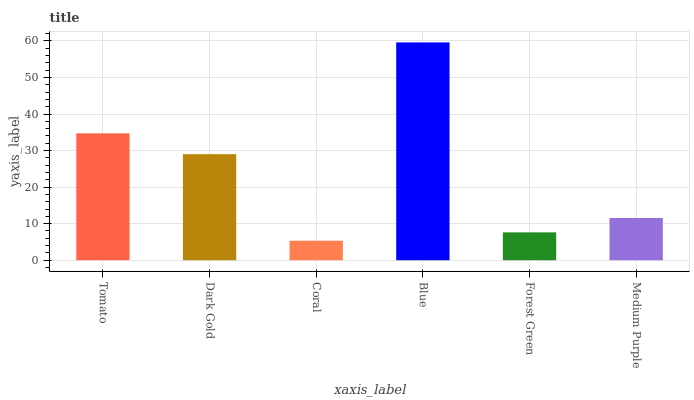Is Coral the minimum?
Answer yes or no. Yes. Is Blue the maximum?
Answer yes or no. Yes. Is Dark Gold the minimum?
Answer yes or no. No. Is Dark Gold the maximum?
Answer yes or no. No. Is Tomato greater than Dark Gold?
Answer yes or no. Yes. Is Dark Gold less than Tomato?
Answer yes or no. Yes. Is Dark Gold greater than Tomato?
Answer yes or no. No. Is Tomato less than Dark Gold?
Answer yes or no. No. Is Dark Gold the high median?
Answer yes or no. Yes. Is Medium Purple the low median?
Answer yes or no. Yes. Is Blue the high median?
Answer yes or no. No. Is Tomato the low median?
Answer yes or no. No. 